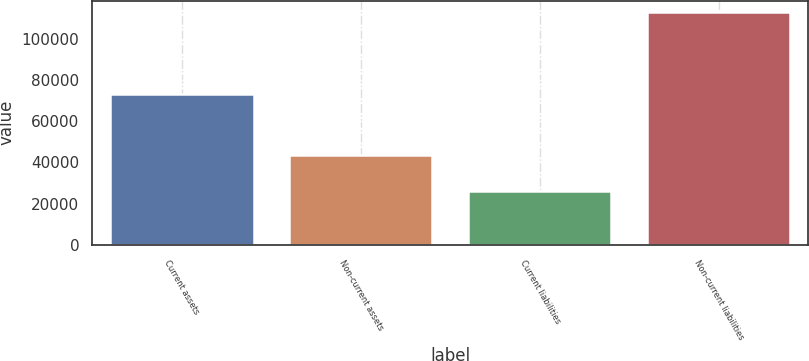Convert chart to OTSL. <chart><loc_0><loc_0><loc_500><loc_500><bar_chart><fcel>Current assets<fcel>Non-current assets<fcel>Current liabilities<fcel>Non-current liabilities<nl><fcel>73284<fcel>43417<fcel>25919<fcel>112959<nl></chart> 